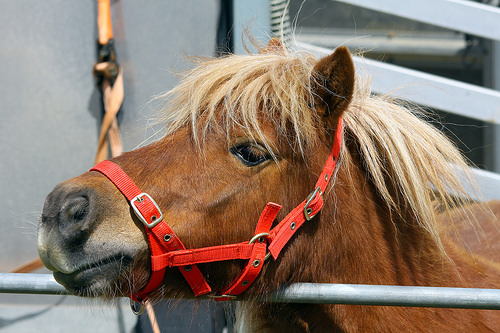<image>
Is there a pony on the harness? Yes. Looking at the image, I can see the pony is positioned on top of the harness, with the harness providing support. 